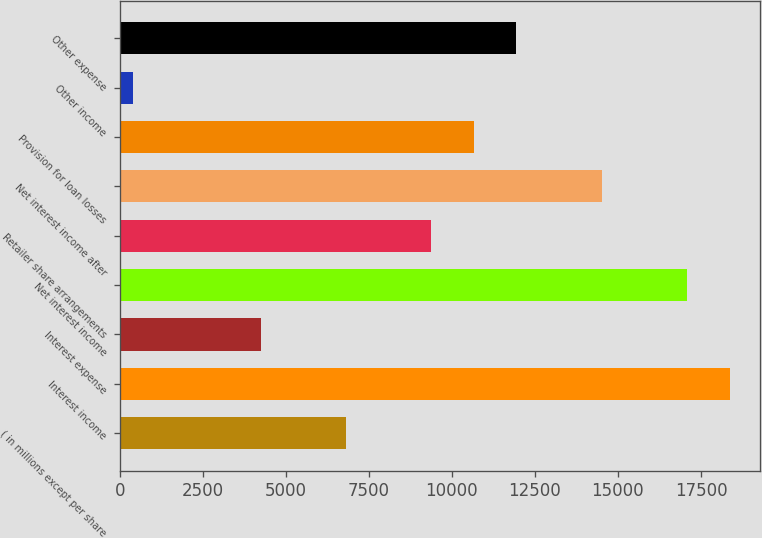Convert chart to OTSL. <chart><loc_0><loc_0><loc_500><loc_500><bar_chart><fcel>( in millions except per share<fcel>Interest income<fcel>Interest expense<fcel>Net interest income<fcel>Retailer share arrangements<fcel>Net interest income after<fcel>Provision for loan losses<fcel>Other income<fcel>Other expense<nl><fcel>6810<fcel>18362.4<fcel>4242.8<fcel>17078.8<fcel>9377.2<fcel>14511.6<fcel>10660.8<fcel>392<fcel>11944.4<nl></chart> 